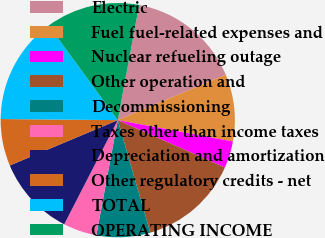Convert chart to OTSL. <chart><loc_0><loc_0><loc_500><loc_500><pie_chart><fcel>Electric<fcel>Fuel fuel-related expenses and<fcel>Nuclear refueling outage<fcel>Other operation and<fcel>Decommissioning<fcel>Taxes other than income taxes<fcel>Depreciation and amortization<fcel>Other regulatory credits - net<fcel>TOTAL<fcel>OPERATING INCOME<nl><fcel>15.74%<fcel>9.26%<fcel>3.71%<fcel>13.89%<fcel>7.41%<fcel>4.63%<fcel>11.11%<fcel>6.48%<fcel>14.81%<fcel>12.96%<nl></chart> 